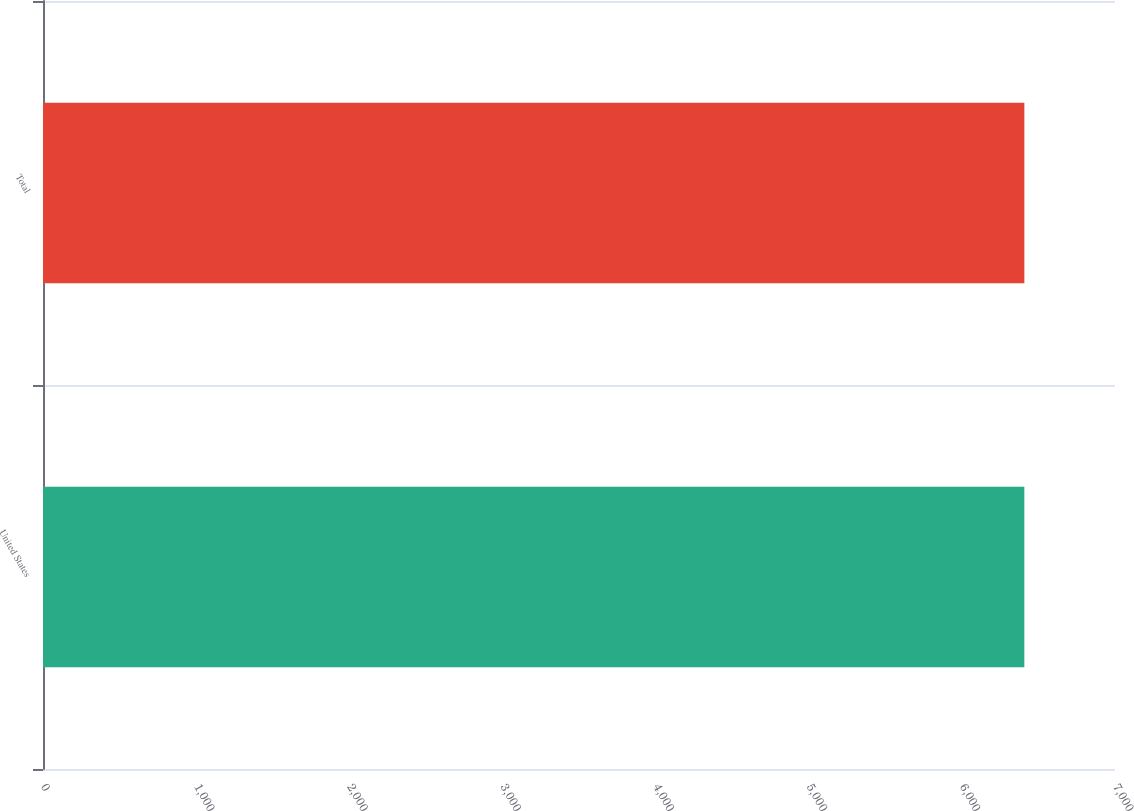<chart> <loc_0><loc_0><loc_500><loc_500><bar_chart><fcel>United States<fcel>Total<nl><fcel>6408<fcel>6408.1<nl></chart> 